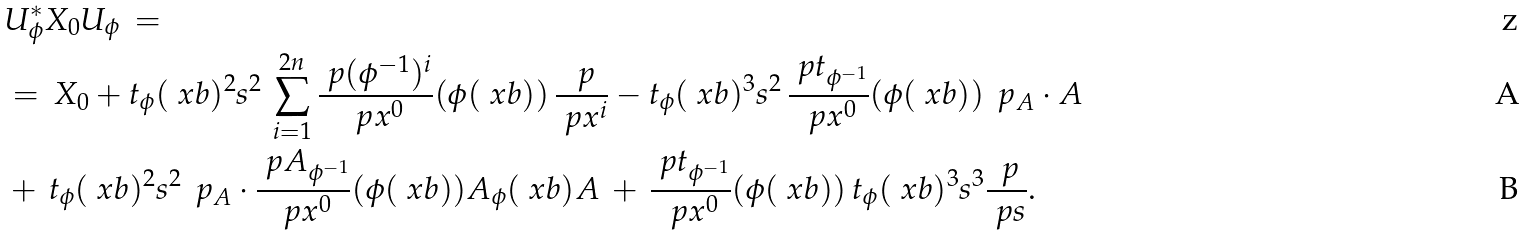Convert formula to latex. <formula><loc_0><loc_0><loc_500><loc_500>& U ^ { \ast } _ { \phi } X _ { 0 } U _ { \phi } \, = \\ & = \, X _ { 0 } + t _ { \phi } ( \ x b ) ^ { 2 } s ^ { 2 } \, \sum _ { i = 1 } ^ { 2 n } \frac { \ p ( \phi ^ { - 1 } ) ^ { i } } { \ p x ^ { 0 } } ( \phi ( \ x b ) ) \, \frac { \ p } { \ p x ^ { i } } - t _ { \phi } ( \ x b ) ^ { 3 } s ^ { 2 } \, \frac { \ p t _ { \phi ^ { - 1 } } } { \ p x ^ { 0 } } ( \phi ( \ x b ) ) \, \ p _ { A } \cdot A \\ & + \, t _ { \phi } ( \ x b ) ^ { 2 } s ^ { 2 } \, \ p _ { A } \cdot \frac { \ p A _ { \phi ^ { - 1 } } } { \ p x ^ { 0 } } ( \phi ( \ x b ) ) A _ { \phi } ( \ x b ) A \, + \, \frac { \ p t _ { \phi ^ { - 1 } } } { \ p x ^ { 0 } } ( \phi ( \ x b ) ) \, t _ { \phi } ( \ x b ) ^ { 3 } s ^ { 3 } \frac { \ p } { \ p s } .</formula> 